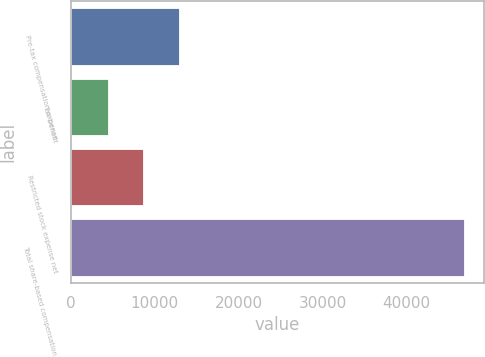Convert chart. <chart><loc_0><loc_0><loc_500><loc_500><bar_chart><fcel>Pre-tax compensation expense<fcel>Tax benefit<fcel>Restricted stock expense net<fcel>Total share-based compensation<nl><fcel>12887.6<fcel>4396<fcel>8641.8<fcel>46854<nl></chart> 